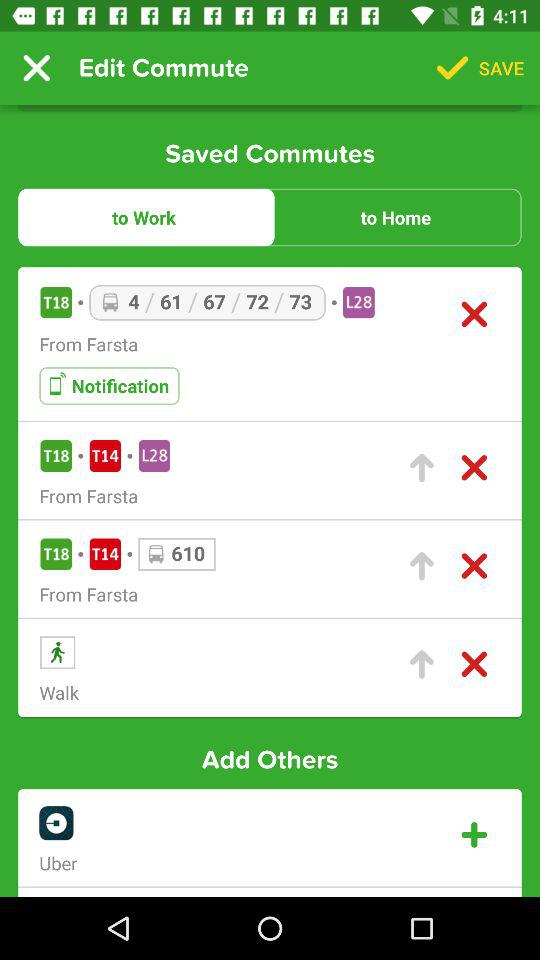What are the other options given for commuting? The other option given for commuting is "Uber". 